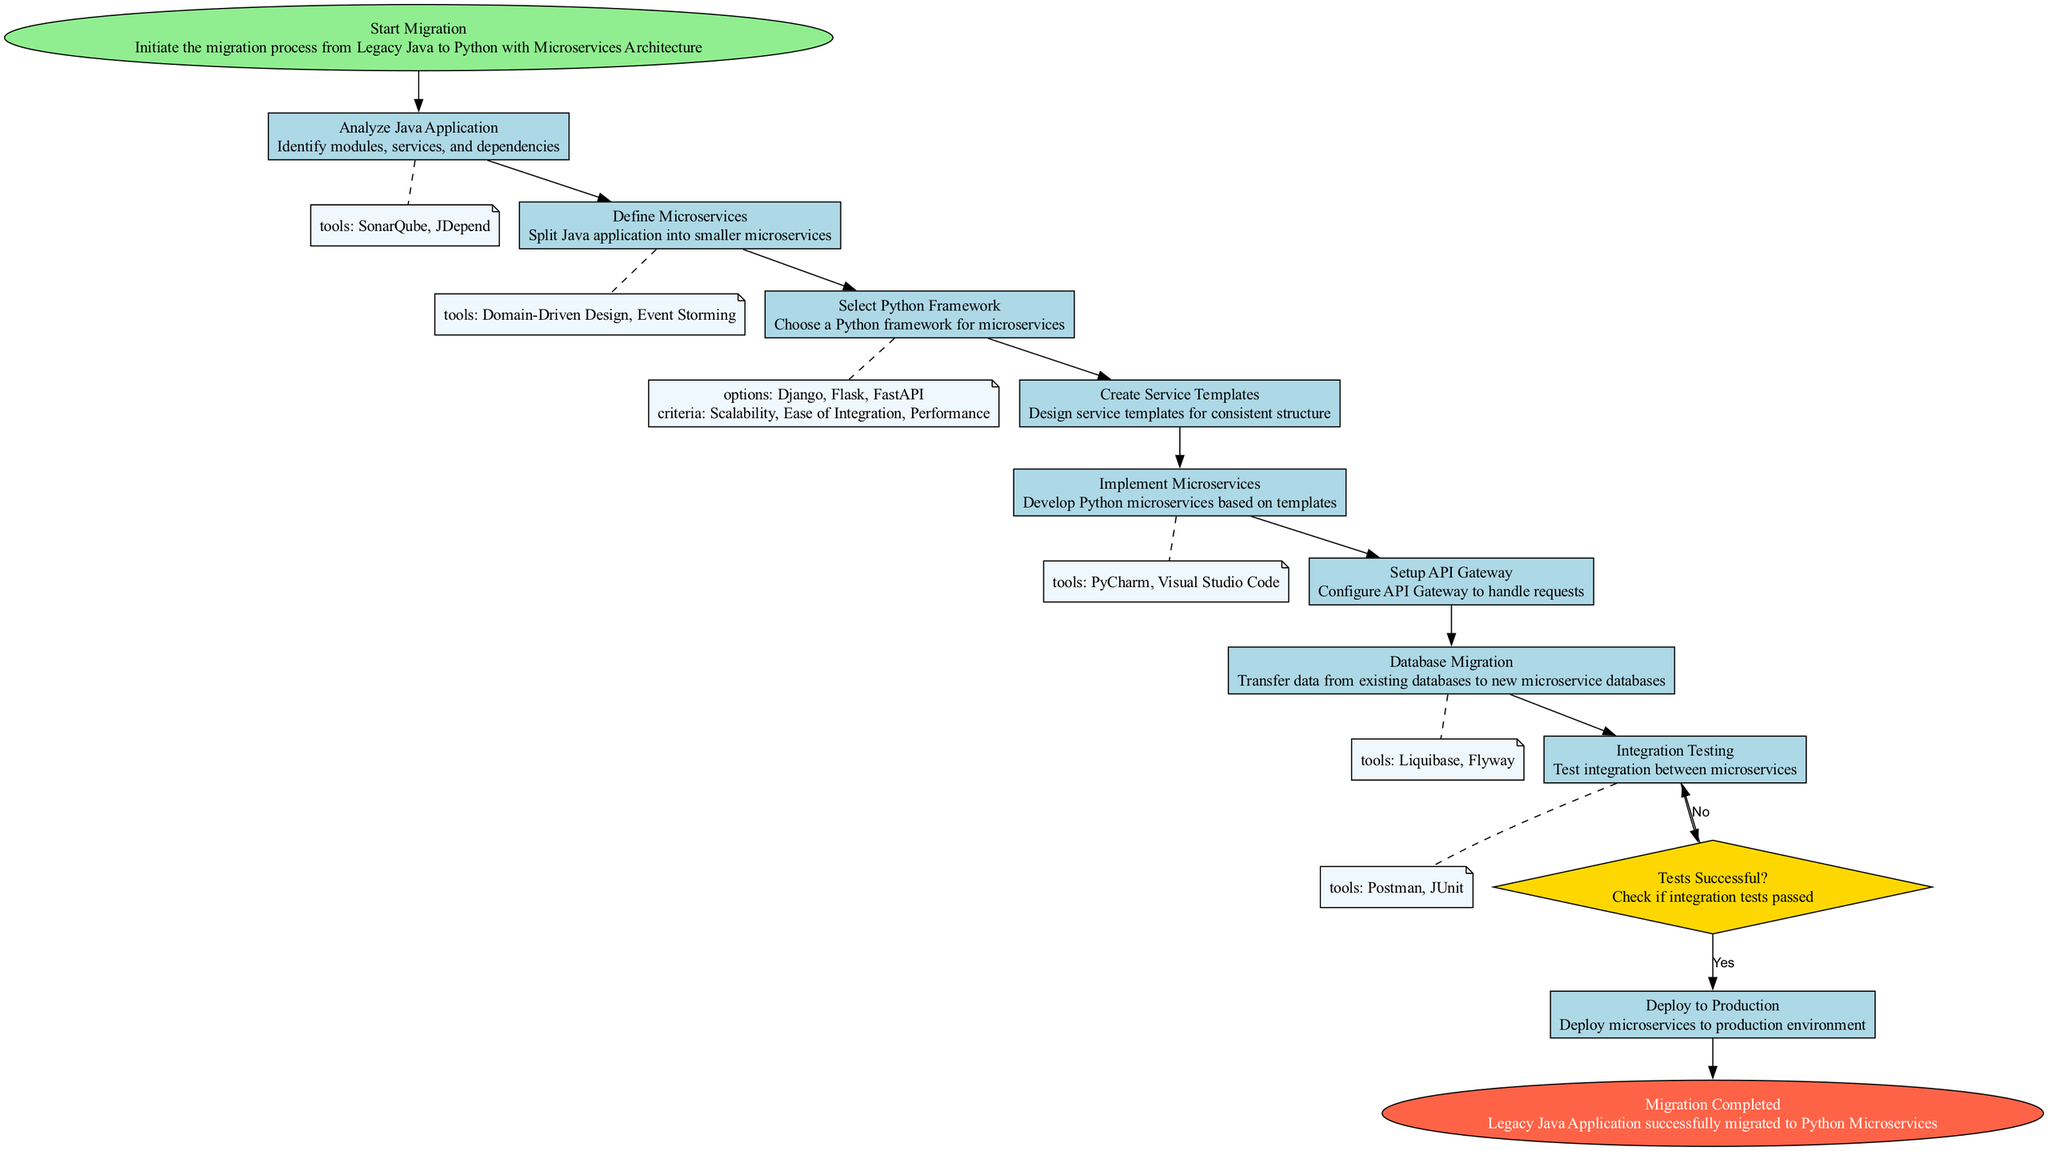What is the first step in the migration process? The diagram starts with the node labeled "Start Migration," indicating that this is the initial step in the process.
Answer: Start Migration How many decision nodes are there in the diagram? By examining the diagram, we can see that there is one decision node labeled "Tests Successful?" indicating there is only one decision point in the flow.
Answer: 1 Which tool is used in the "Analyze Java Application" step? The diagram lists "SonarQube" and "JDepend" as tools used in the "Analyze Java Application" process, as detailed in the corresponding node.
Answer: SonarQube, JDepend What follows the "Create Service Templates" process? According to the transitions in the diagram, "Implement Microservices" directly follows "Create Service Templates," indicating the order of operations in the migration process.
Answer: Implement Microservices What is the last step of the migration flowchart? The flowchart ends with the node labeled "Migration Completed," which signifies the conclusion of the migration process.
Answer: Migration Completed What condition leads to re-testing in the migration process? The transition from the "Tests Successful?" decision node to "Integration Testing" is conditioned on a "No," meaning if tests are not successful, re-testing occurs at that stage.
Answer: No Which microservices are options for the "Select Python Framework"? The options provided in the corresponding node for selecting a Python framework include "Django," "Flask," and "FastAPI." These are identified in the "Select Python Framework" process.
Answer: Django, Flask, FastAPI What tools are mentioned for "Database Migration"? The tools for "Database Migration" include "Liquibase" and "Flyway," as specified in the details of that process node in the diagram.
Answer: Liquibase, Flyway How many edges connect the "Deploy to Production" node? The "Deploy to Production" node is connected by one edge that leads to the "Migration Completed" node, illustrating the flow toward final completion of the process.
Answer: 1 